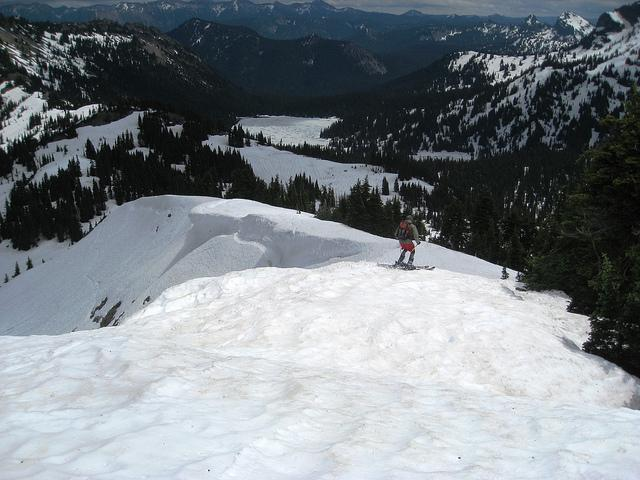From where did this person directly come? Please explain your reasoning. up high. The man is going down a mountain so must have came from up higher. 